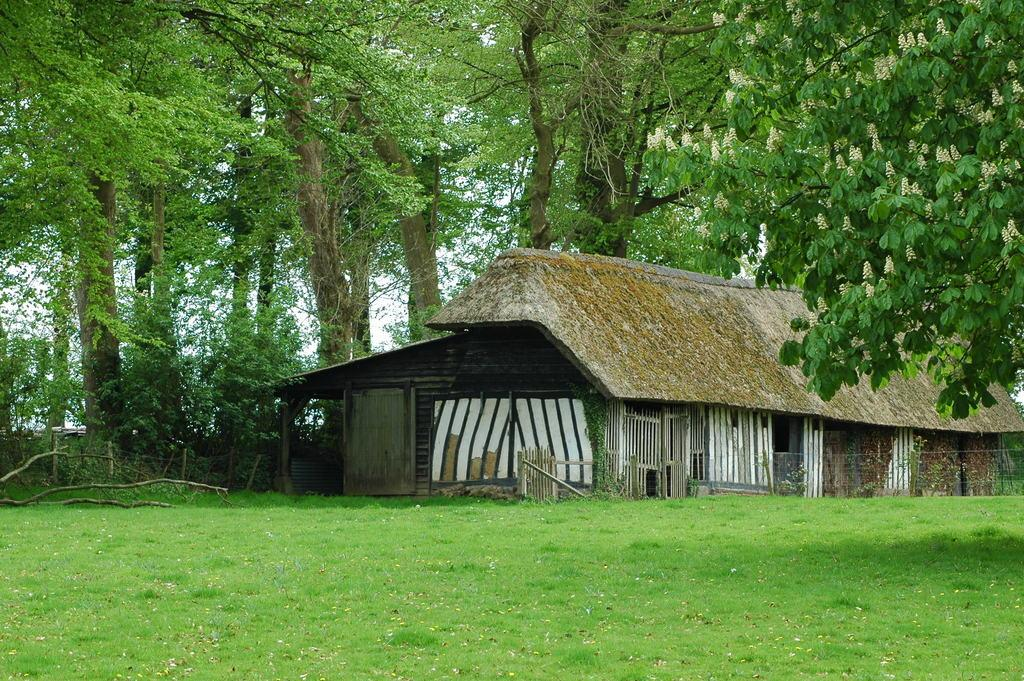What can be seen in the foreground of the picture? There are dry leaves and grass in the foreground of the picture. What is located in the middle of the picture? There are trees and plants in the middle of the picture, as well as a thatched hut. What is visible in the background of the picture? There is sky visible in the background of the picture. What color is the tongue of the animal in the picture? There is no animal with a tongue present in the image. What happens to the rake when it is used in the picture? There is no rake present in the image. 